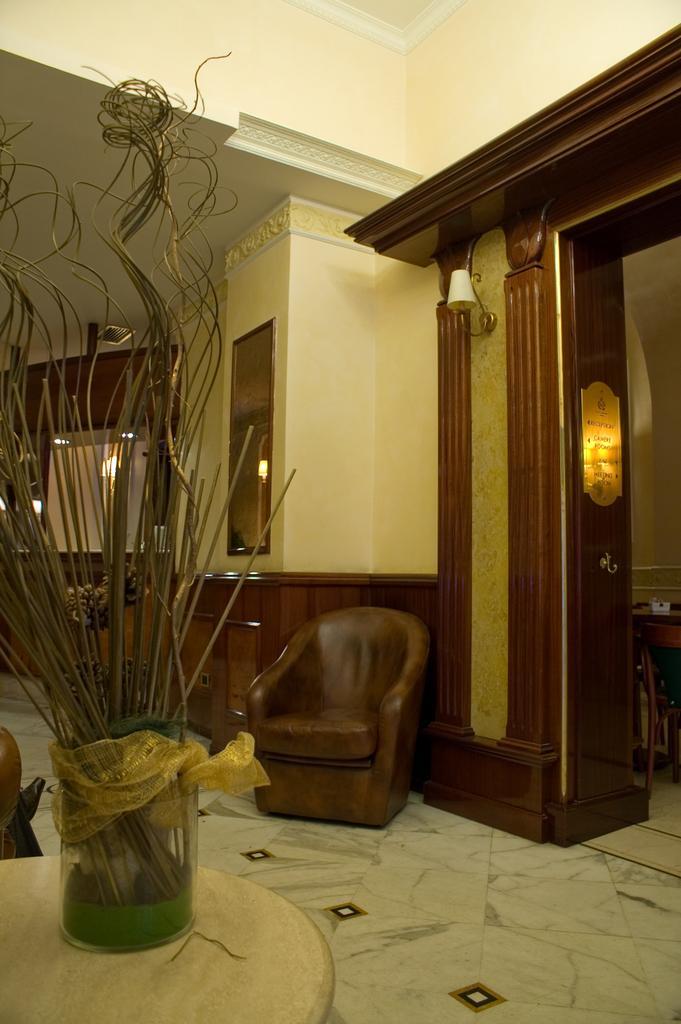How would you summarize this image in a sentence or two? In this image there is a table, on that table there is flower vase, in the background there is a chair and a wall for that wall there is a window and lights at the top there is a ceiling. 